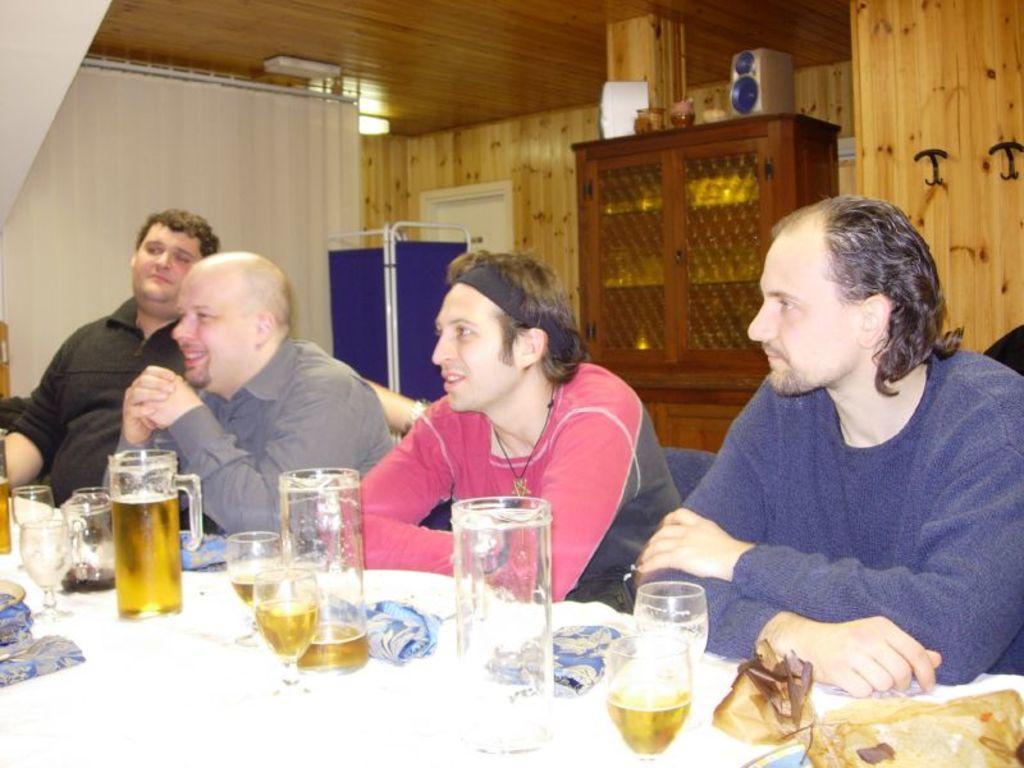In one or two sentences, can you explain what this image depicts? In this image there is a table on which there are glasses, jars and other objects. There are people sitting on chairs. In the background of the image there is wooden wall. There is a cupboard with objects on it. At the top of the image there is ceiling. 